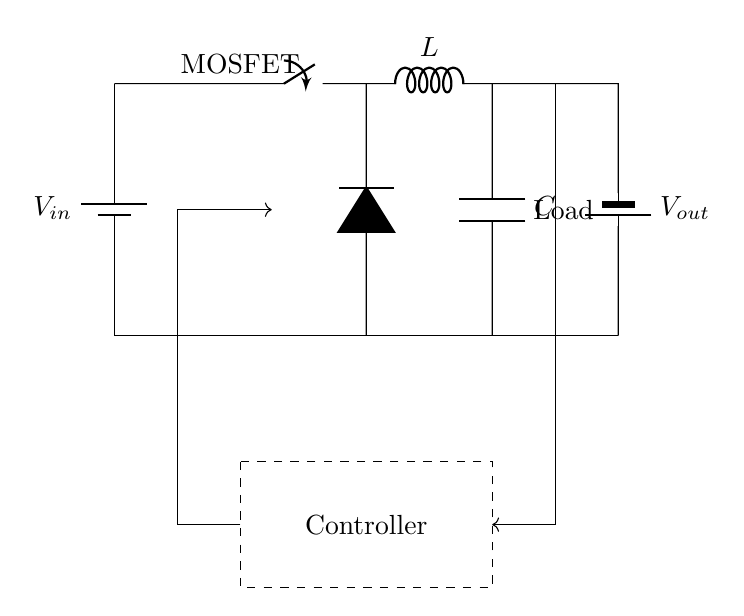What is the input voltage of the circuit? The input voltage is represented by \( V_{in} \), which is connected to the top of the circuit.
Answer: \( V_{in} \) What type of switch is used in this circuit? The switch is labeled as "MOSFET," indicating it is a type of metal-oxide-semiconductor field-effect transistor used for rapidly switching the circuit on and off.
Answer: MOSFET Which component stores energy in this SMPS circuit? The inductor, labeled as \( L \), is responsible for storing energy in the form of a magnetic field when current flows through it.
Answer: Inductor What are the two main components used to filter the output voltage? The components used to filter the output voltage are the inductor and the capacitor, which work together to smooth out the output voltage.
Answer: Inductor and Capacitor Explain how the feedback mechanism operates in this SMPS. The feedback mechanism works by monitoring the output voltage and sending a control signal back to the controller to adjust the duty cycle of the MOSFET. This ensures that the output voltage remains stable under varying load conditions. This involves the output voltage being compared to a reference voltage internally, leading to adjustments in switching.
Answer: Feedback mechanism What is the purpose of the controller in this circuit? The controller regulates the switching of the MOSFET based on the feedback from the output voltage, ensuring proper operation and stable output as load conditions change.
Answer: Regulation of MOSFET switching What can be inferred about the load connected to this circuit? The load is indicated in the circuit diagram and is typically where the regulated output voltage is delivered; it can vary in nature, but it must match the specifications for which the SMPS is designed.
Answer: Load 